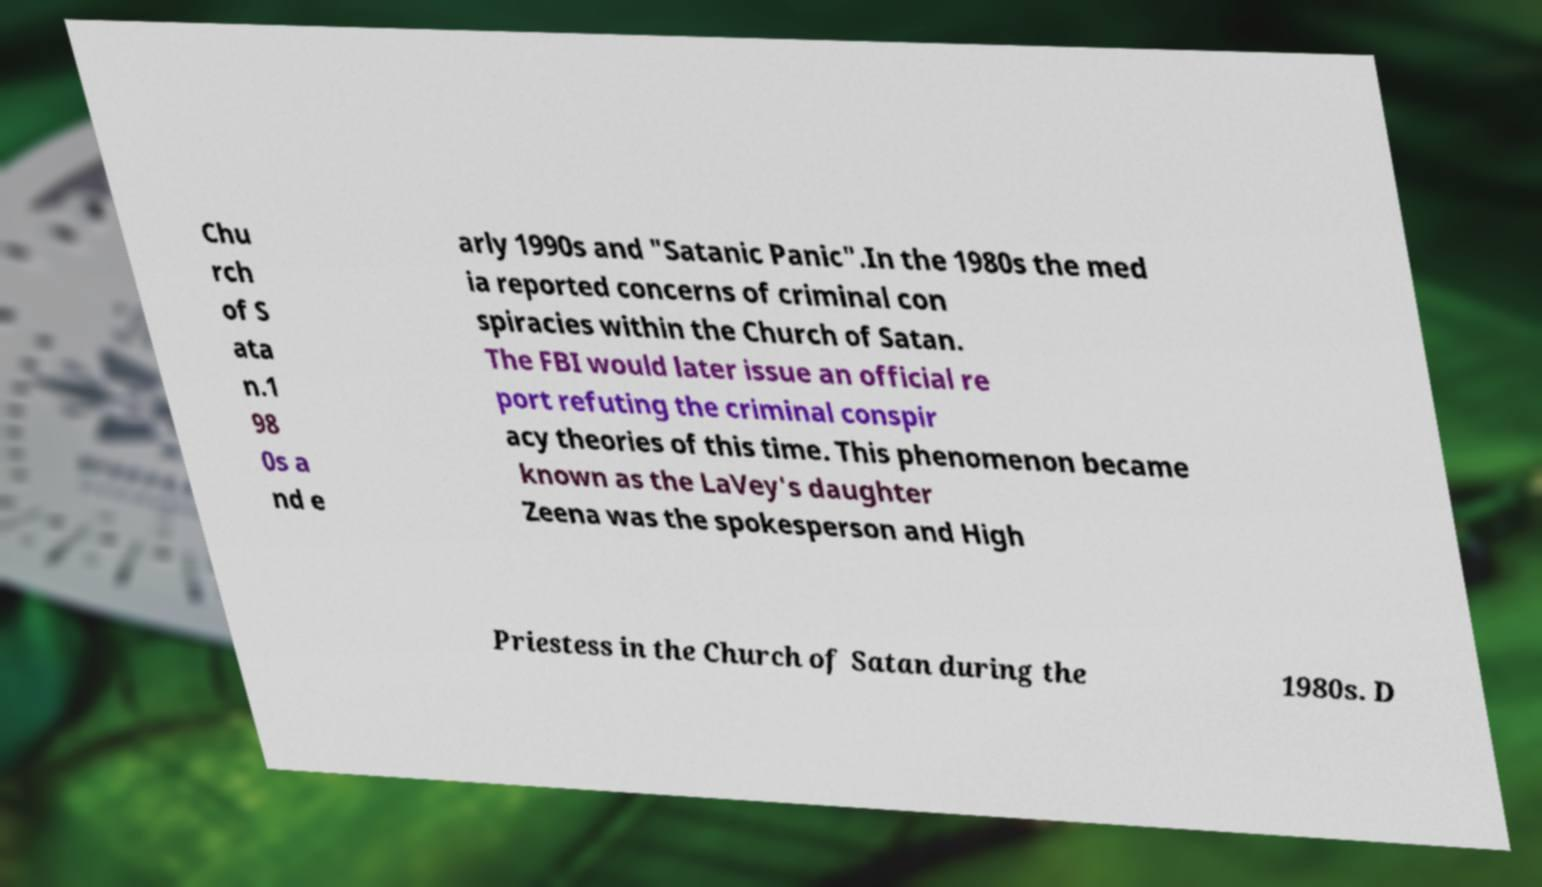For documentation purposes, I need the text within this image transcribed. Could you provide that? Chu rch of S ata n.1 98 0s a nd e arly 1990s and "Satanic Panic".In the 1980s the med ia reported concerns of criminal con spiracies within the Church of Satan. The FBI would later issue an official re port refuting the criminal conspir acy theories of this time. This phenomenon became known as the LaVey's daughter Zeena was the spokesperson and High Priestess in the Church of Satan during the 1980s. D 